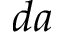<formula> <loc_0><loc_0><loc_500><loc_500>d a</formula> 